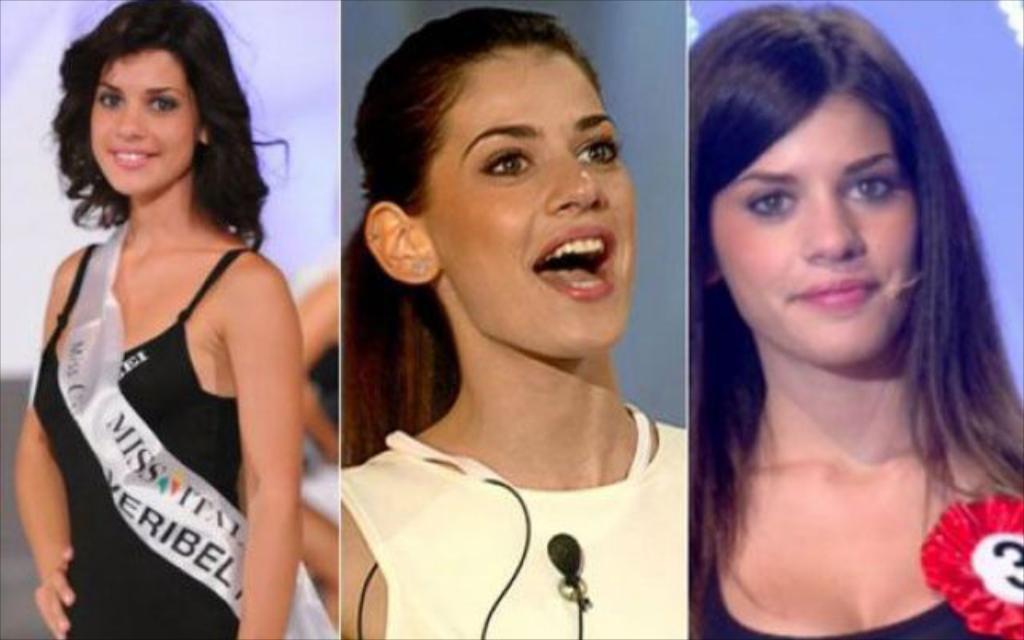How would you summarize this image in a sentence or two? In the image we can see three women wearing clothes, this is a banner, microphone and a batch. 